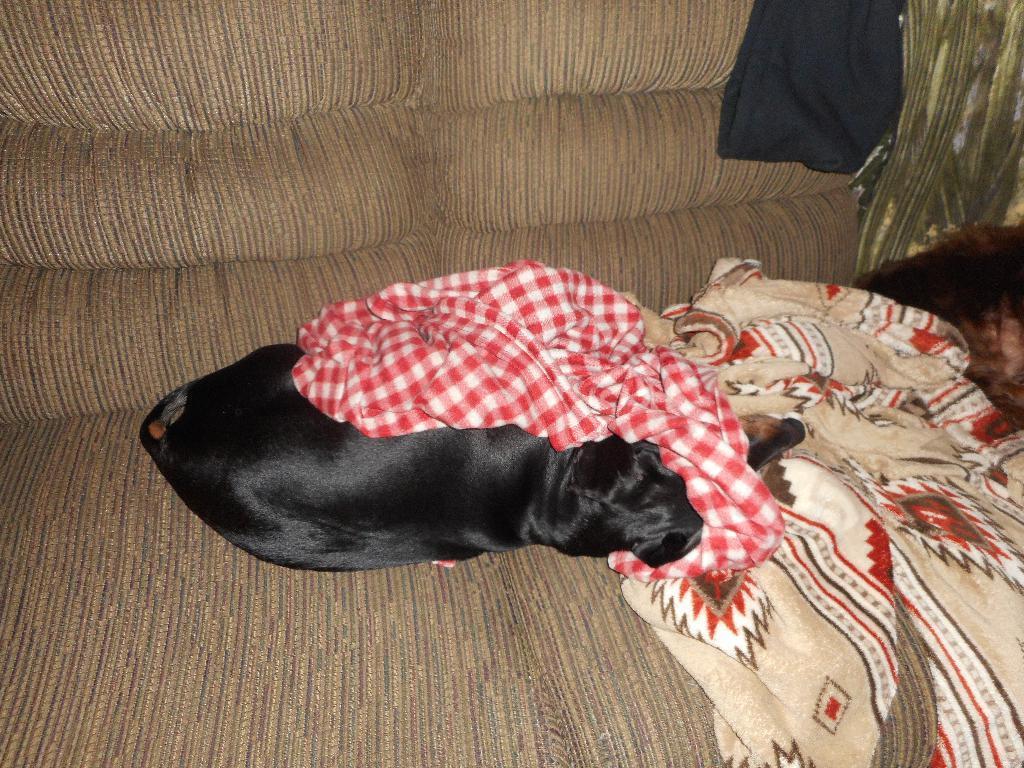Can you describe this image briefly? In the image there is a dog laying on sofa with bed sheets beside it. 